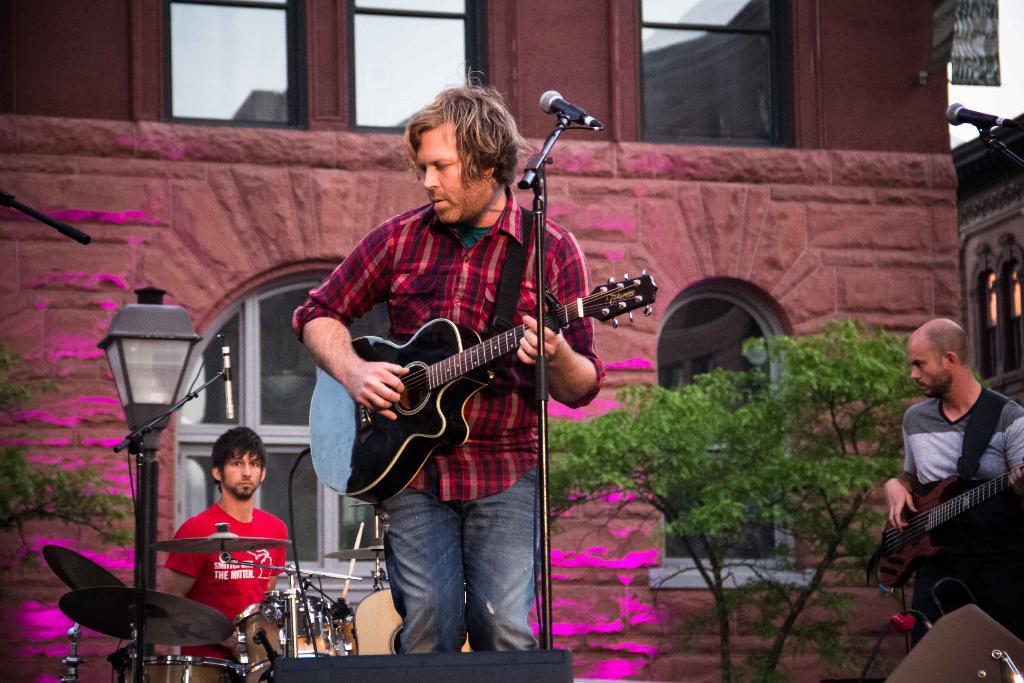In one or two sentences, can you explain what this image depicts? The person wearing red shirt is holding guitar in his hand and there is mike in front of him, The person wearing red T-shirt is playing drums and the person wearing white T-shirt is playing guitar and there is a building in background which is red in color and there is also tree in background 